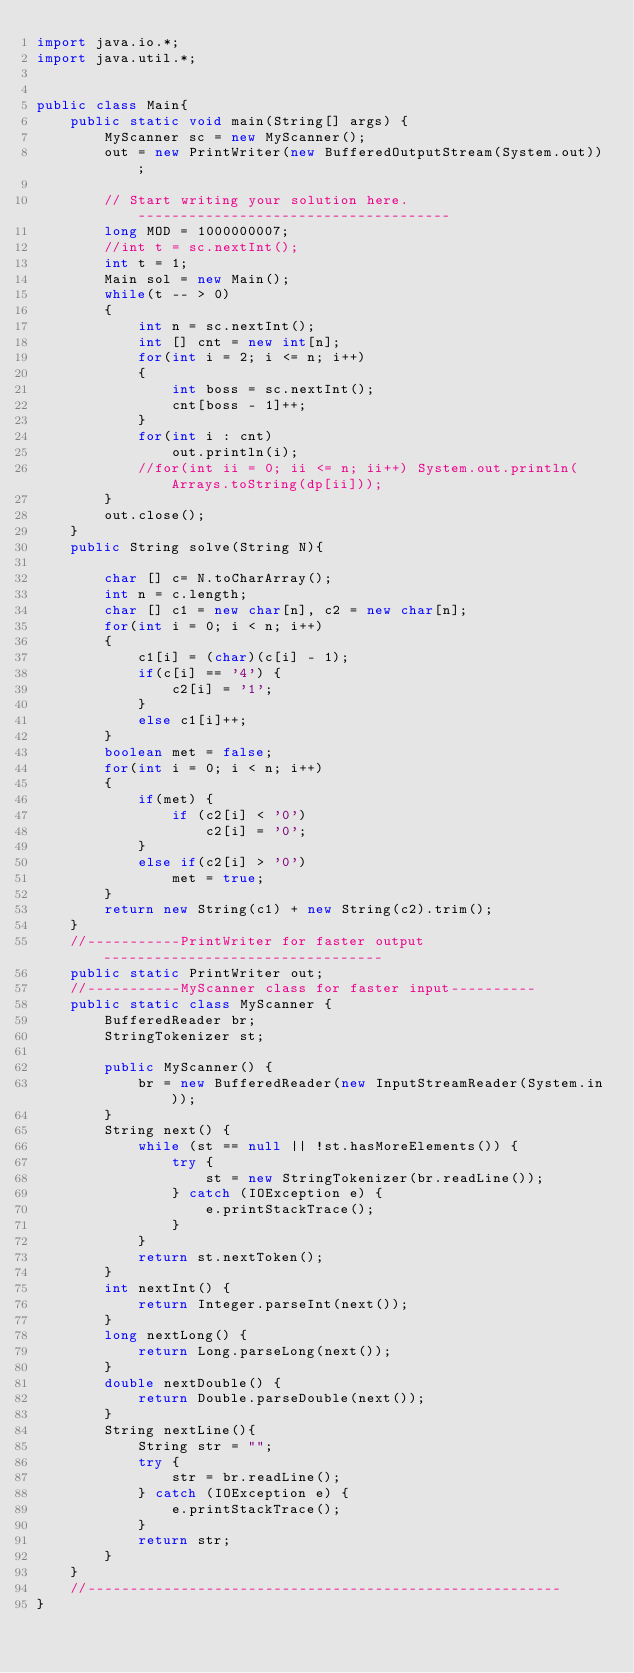Convert code to text. <code><loc_0><loc_0><loc_500><loc_500><_Java_>import java.io.*;
import java.util.*;


public class Main{
    public static void main(String[] args) {
        MyScanner sc = new MyScanner();
        out = new PrintWriter(new BufferedOutputStream(System.out));

        // Start writing your solution here. -------------------------------------
        long MOD = 1000000007;
        //int t = sc.nextInt();
        int t = 1;
        Main sol = new Main();
        while(t -- > 0)
        {
            int n = sc.nextInt();
            int [] cnt = new int[n];
            for(int i = 2; i <= n; i++)
            {
                int boss = sc.nextInt();
                cnt[boss - 1]++;
            }
            for(int i : cnt)
                out.println(i);
            //for(int ii = 0; ii <= n; ii++) System.out.println(Arrays.toString(dp[ii]));
        }
        out.close();
    }
    public String solve(String N){

        char [] c= N.toCharArray();
        int n = c.length;
        char [] c1 = new char[n], c2 = new char[n];
        for(int i = 0; i < n; i++)
        {
            c1[i] = (char)(c[i] - 1);
            if(c[i] == '4') {
                c2[i] = '1';
            }
            else c1[i]++;
        }
        boolean met = false;
        for(int i = 0; i < n; i++)
        {
            if(met) {
                if (c2[i] < '0')
                    c2[i] = '0';
            }
            else if(c2[i] > '0')
                met = true;
        }
        return new String(c1) + new String(c2).trim();
    }
    //-----------PrintWriter for faster output---------------------------------
    public static PrintWriter out;
    //-----------MyScanner class for faster input----------
    public static class MyScanner {
        BufferedReader br;
        StringTokenizer st;

        public MyScanner() {
            br = new BufferedReader(new InputStreamReader(System.in));
        }
        String next() {
            while (st == null || !st.hasMoreElements()) {
                try {
                    st = new StringTokenizer(br.readLine());
                } catch (IOException e) {
                    e.printStackTrace();
                }
            }
            return st.nextToken();
        }
        int nextInt() {
            return Integer.parseInt(next());
        }
        long nextLong() {
            return Long.parseLong(next());
        }
        double nextDouble() {
            return Double.parseDouble(next());
        }
        String nextLine(){
            String str = "";
            try {
                str = br.readLine();
            } catch (IOException e) {
                e.printStackTrace();
            }
            return str;
        }
    }
    //--------------------------------------------------------
}</code> 